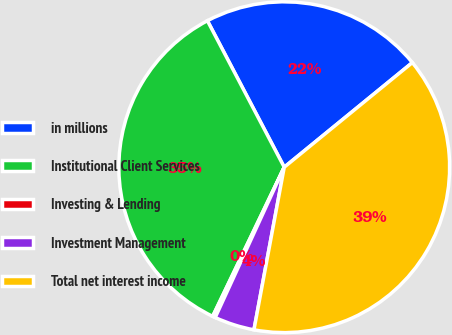Convert chart to OTSL. <chart><loc_0><loc_0><loc_500><loc_500><pie_chart><fcel>in millions<fcel>Institutional Client Services<fcel>Investing & Lending<fcel>Investment Management<fcel>Total net interest income<nl><fcel>21.79%<fcel>35.19%<fcel>0.27%<fcel>3.92%<fcel>38.83%<nl></chart> 